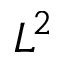<formula> <loc_0><loc_0><loc_500><loc_500>L ^ { 2 }</formula> 